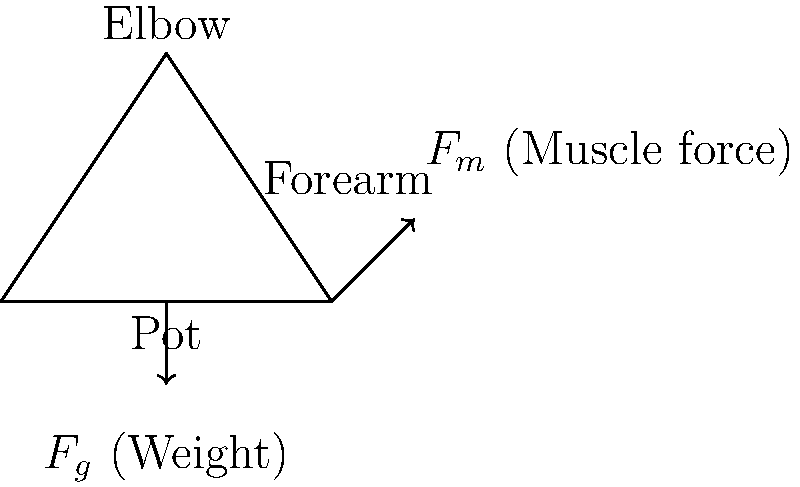You're preparing your favorite comfort food, a hearty stew, in a heavy pot. As you lift the pot with one hand, your elbow forms a 90-degree angle. The pot weighs 15 kg, and your forearm is 30 cm long. What is the magnitude of the force exerted by your biceps muscle to hold the pot steady, assuming the biceps attaches 5 cm from the elbow on the forearm? Let's approach this step-by-step:

1) First, we need to calculate the weight of the pot:
   $F_g = mg = 15 \text{ kg} \times 9.8 \text{ m/s}^2 = 147 \text{ N}$

2) The elbow joint acts as a pivot point in this scenario. We can use the principle of moments to solve this problem.

3) The moment caused by the weight of the pot:
   $M_g = F_g \times d_g = 147 \text{ N} \times 0.3 \text{ m} = 44.1 \text{ Nm}$

4) For equilibrium, this moment must be balanced by the moment created by the biceps muscle force:
   $M_m = F_m \times d_m$
   where $d_m$ is the perpendicular distance from the elbow to the line of action of the muscle force (5 cm = 0.05 m)

5) In equilibrium: $M_g = M_m$
   $44.1 = F_m \times 0.05$

6) Solving for $F_m$:
   $F_m = 44.1 \div 0.05 = 882 \text{ N}$

Therefore, the biceps muscle needs to exert a force of 882 N to hold the pot steady.
Answer: 882 N 